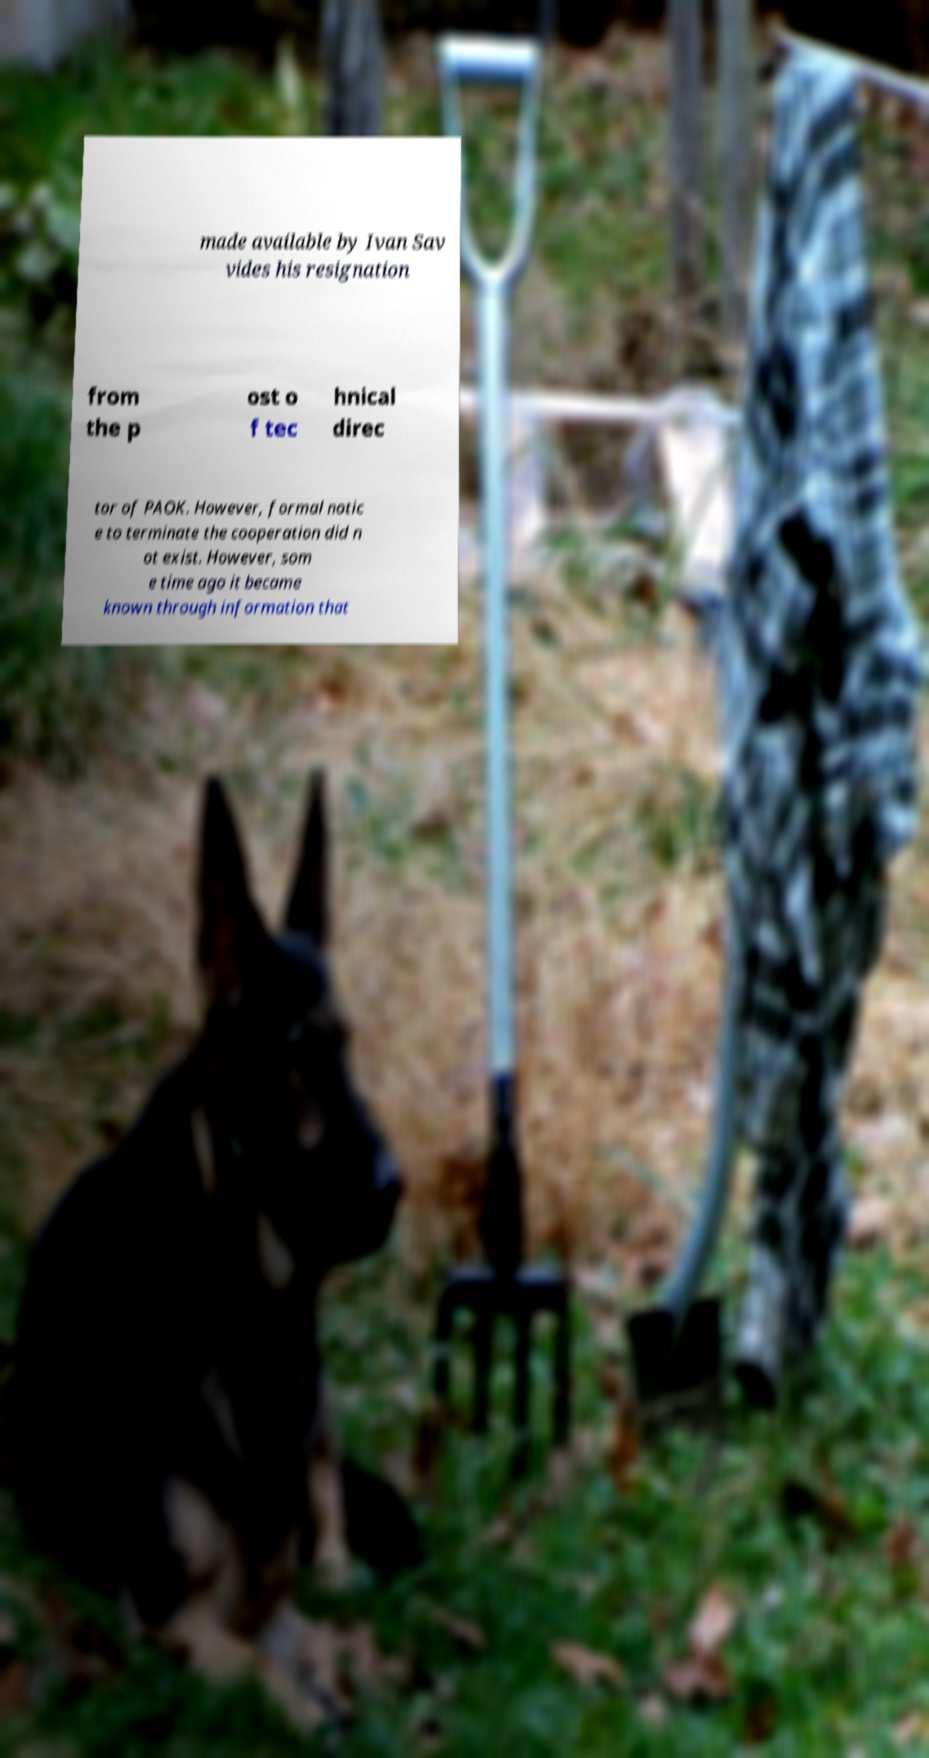Please identify and transcribe the text found in this image. made available by Ivan Sav vides his resignation from the p ost o f tec hnical direc tor of PAOK. However, formal notic e to terminate the cooperation did n ot exist. However, som e time ago it became known through information that 